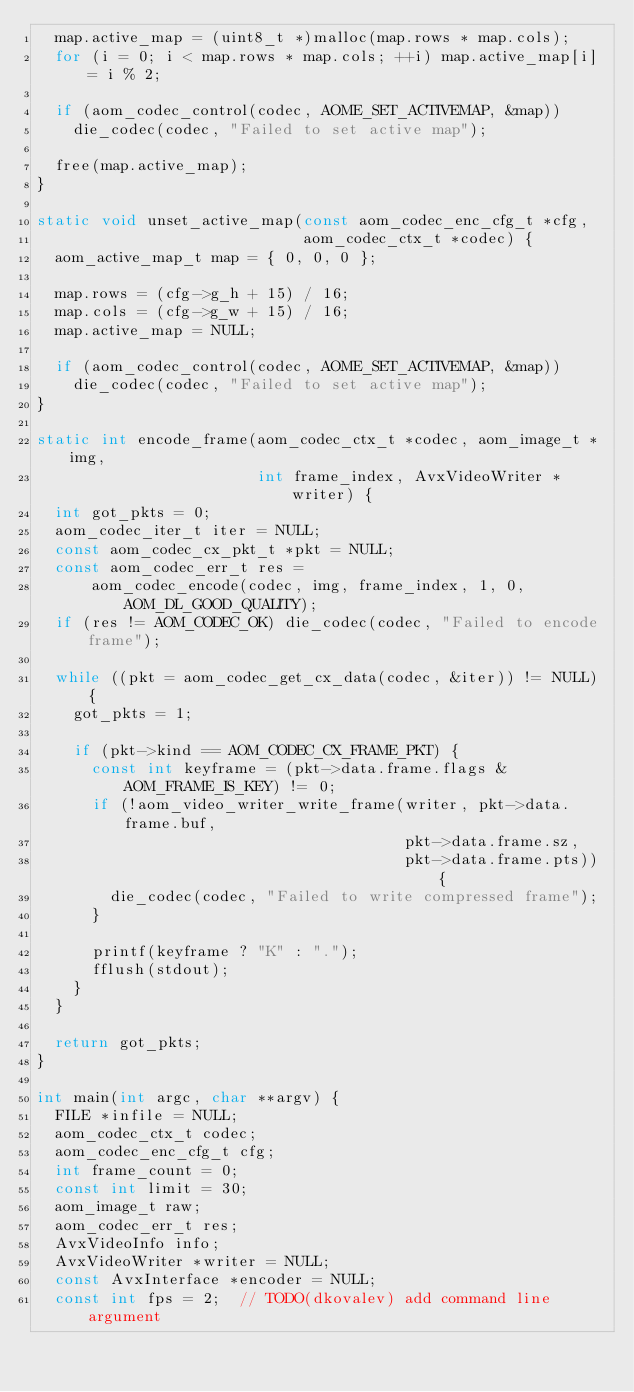<code> <loc_0><loc_0><loc_500><loc_500><_C_>  map.active_map = (uint8_t *)malloc(map.rows * map.cols);
  for (i = 0; i < map.rows * map.cols; ++i) map.active_map[i] = i % 2;

  if (aom_codec_control(codec, AOME_SET_ACTIVEMAP, &map))
    die_codec(codec, "Failed to set active map");

  free(map.active_map);
}

static void unset_active_map(const aom_codec_enc_cfg_t *cfg,
                             aom_codec_ctx_t *codec) {
  aom_active_map_t map = { 0, 0, 0 };

  map.rows = (cfg->g_h + 15) / 16;
  map.cols = (cfg->g_w + 15) / 16;
  map.active_map = NULL;

  if (aom_codec_control(codec, AOME_SET_ACTIVEMAP, &map))
    die_codec(codec, "Failed to set active map");
}

static int encode_frame(aom_codec_ctx_t *codec, aom_image_t *img,
                        int frame_index, AvxVideoWriter *writer) {
  int got_pkts = 0;
  aom_codec_iter_t iter = NULL;
  const aom_codec_cx_pkt_t *pkt = NULL;
  const aom_codec_err_t res =
      aom_codec_encode(codec, img, frame_index, 1, 0, AOM_DL_GOOD_QUALITY);
  if (res != AOM_CODEC_OK) die_codec(codec, "Failed to encode frame");

  while ((pkt = aom_codec_get_cx_data(codec, &iter)) != NULL) {
    got_pkts = 1;

    if (pkt->kind == AOM_CODEC_CX_FRAME_PKT) {
      const int keyframe = (pkt->data.frame.flags & AOM_FRAME_IS_KEY) != 0;
      if (!aom_video_writer_write_frame(writer, pkt->data.frame.buf,
                                        pkt->data.frame.sz,
                                        pkt->data.frame.pts)) {
        die_codec(codec, "Failed to write compressed frame");
      }

      printf(keyframe ? "K" : ".");
      fflush(stdout);
    }
  }

  return got_pkts;
}

int main(int argc, char **argv) {
  FILE *infile = NULL;
  aom_codec_ctx_t codec;
  aom_codec_enc_cfg_t cfg;
  int frame_count = 0;
  const int limit = 30;
  aom_image_t raw;
  aom_codec_err_t res;
  AvxVideoInfo info;
  AvxVideoWriter *writer = NULL;
  const AvxInterface *encoder = NULL;
  const int fps = 2;  // TODO(dkovalev) add command line argument</code> 